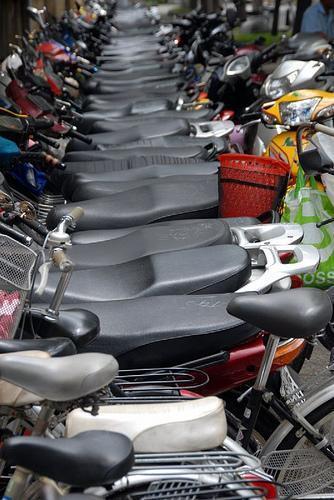How many bicycles can you see?
Give a very brief answer. 3. How many motorcycles are in the picture?
Give a very brief answer. 10. 